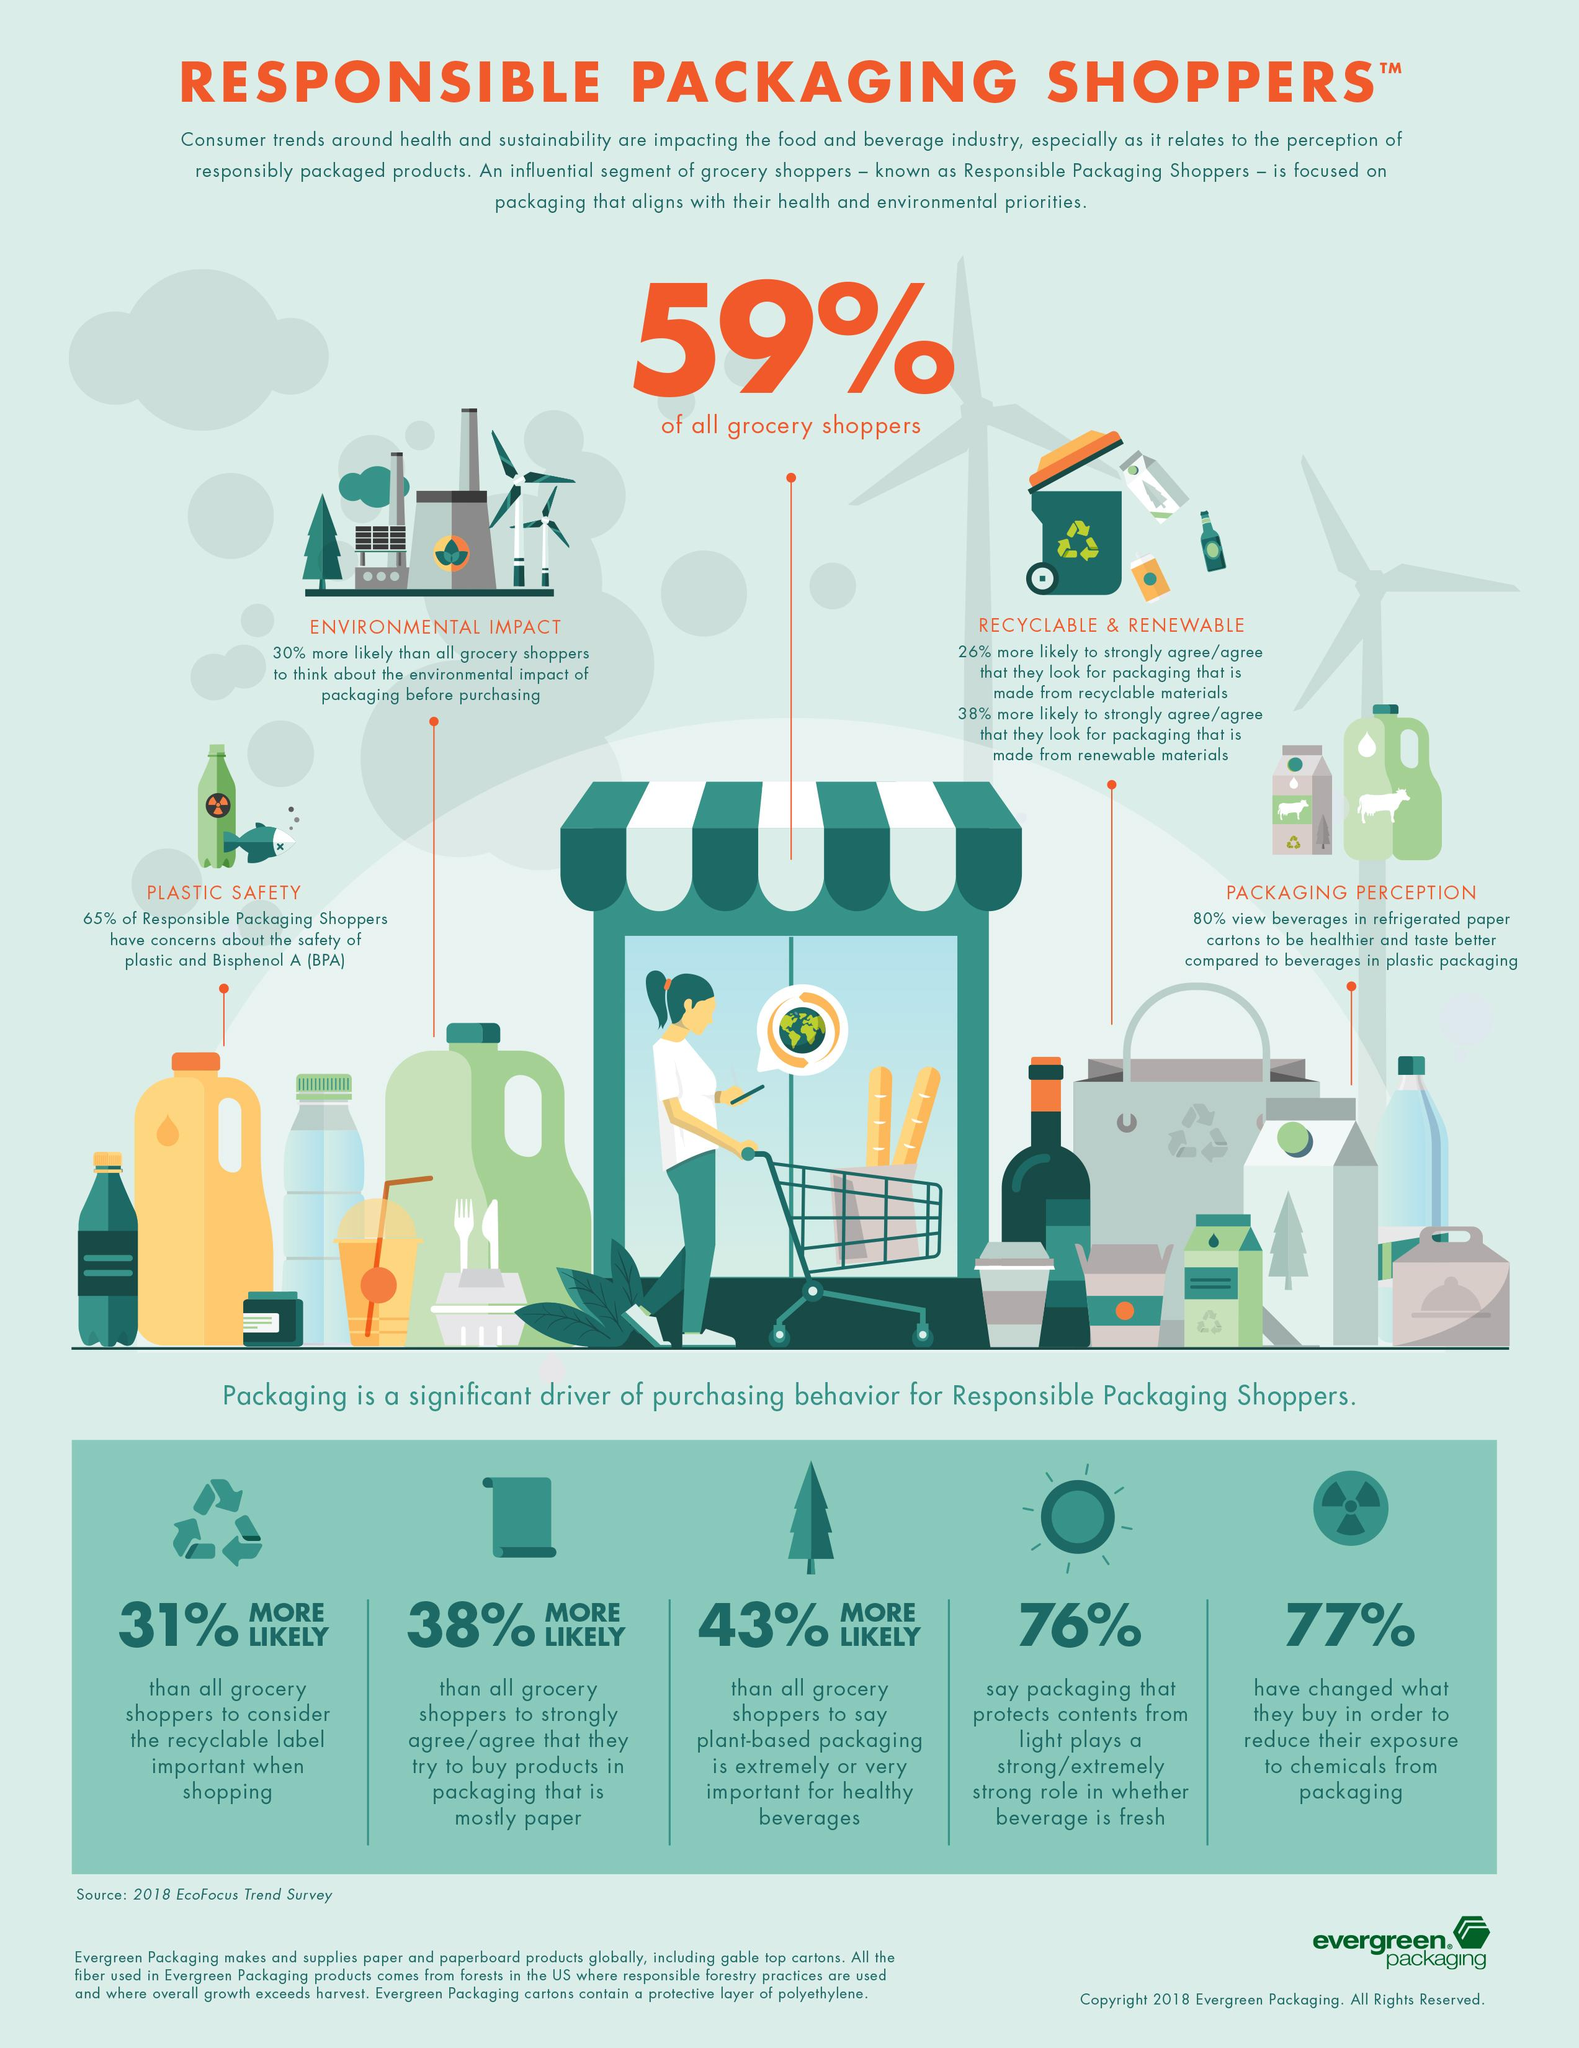Identify some key points in this picture. A significant proportion of Responsible Packaging Shoppers, approximately 35%, show no concern about the safety of plastic and Bisphenol A. 